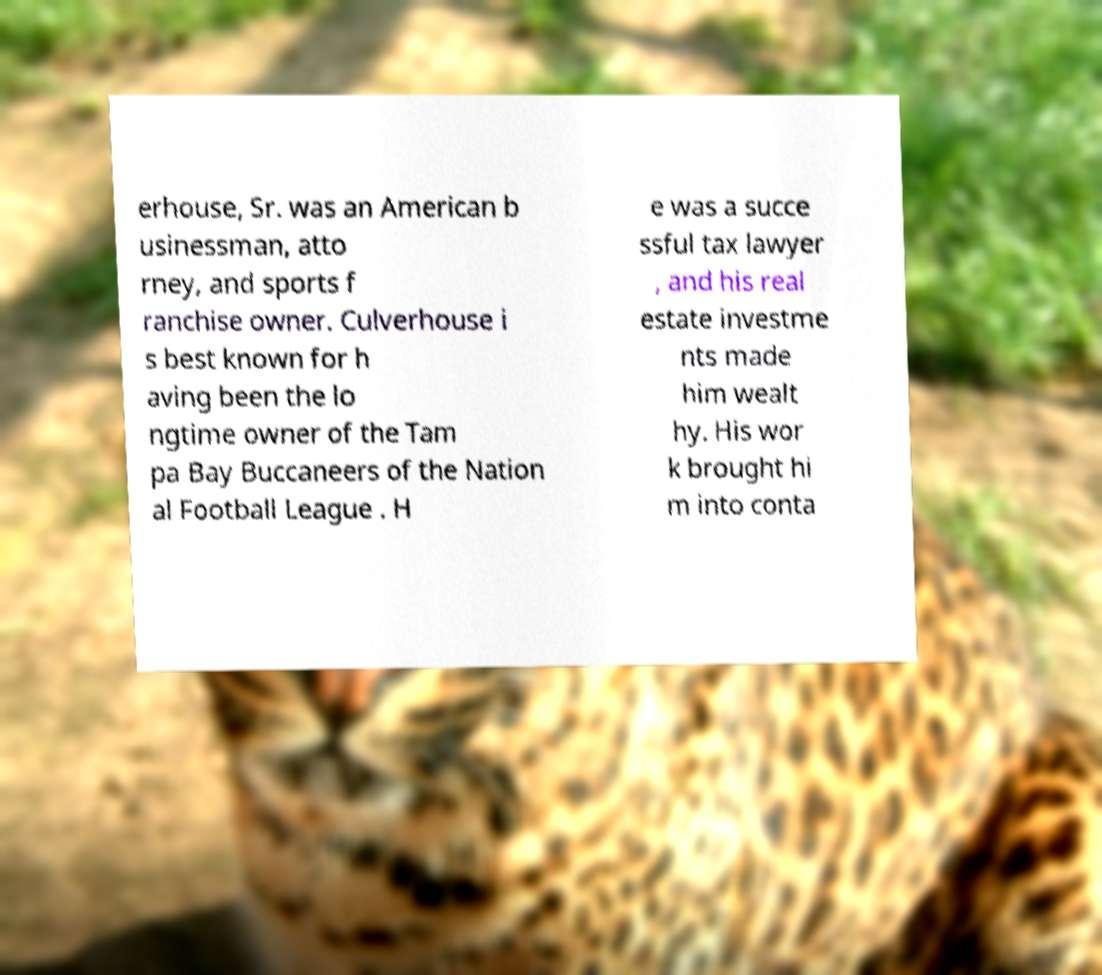Please read and relay the text visible in this image. What does it say? erhouse, Sr. was an American b usinessman, atto rney, and sports f ranchise owner. Culverhouse i s best known for h aving been the lo ngtime owner of the Tam pa Bay Buccaneers of the Nation al Football League . H e was a succe ssful tax lawyer , and his real estate investme nts made him wealt hy. His wor k brought hi m into conta 